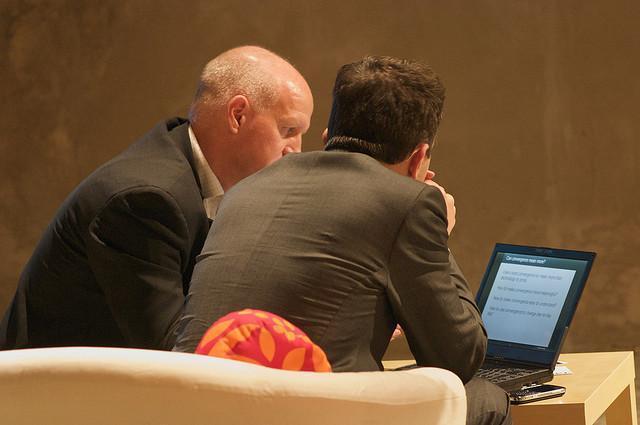How many people are in the picture?
Give a very brief answer. 2. 